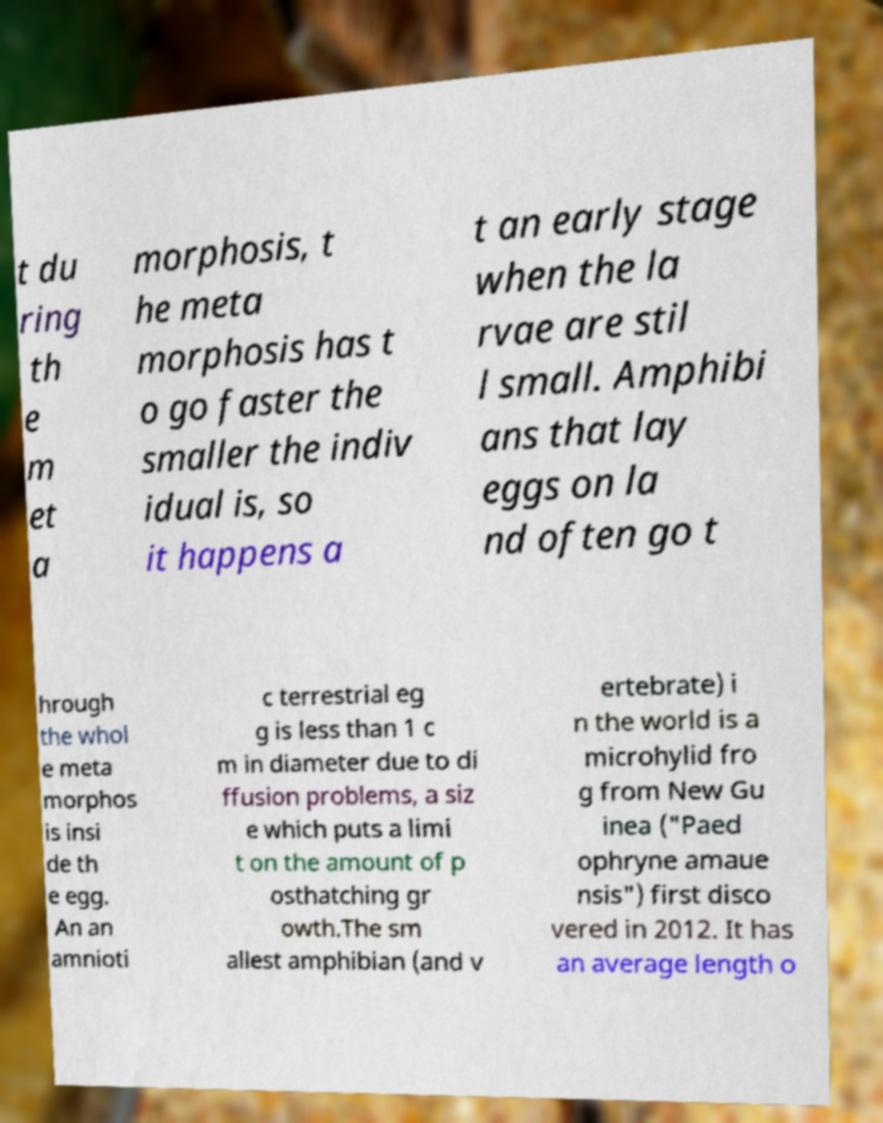What messages or text are displayed in this image? I need them in a readable, typed format. t du ring th e m et a morphosis, t he meta morphosis has t o go faster the smaller the indiv idual is, so it happens a t an early stage when the la rvae are stil l small. Amphibi ans that lay eggs on la nd often go t hrough the whol e meta morphos is insi de th e egg. An an amnioti c terrestrial eg g is less than 1 c m in diameter due to di ffusion problems, a siz e which puts a limi t on the amount of p osthatching gr owth.The sm allest amphibian (and v ertebrate) i n the world is a microhylid fro g from New Gu inea ("Paed ophryne amaue nsis") first disco vered in 2012. It has an average length o 